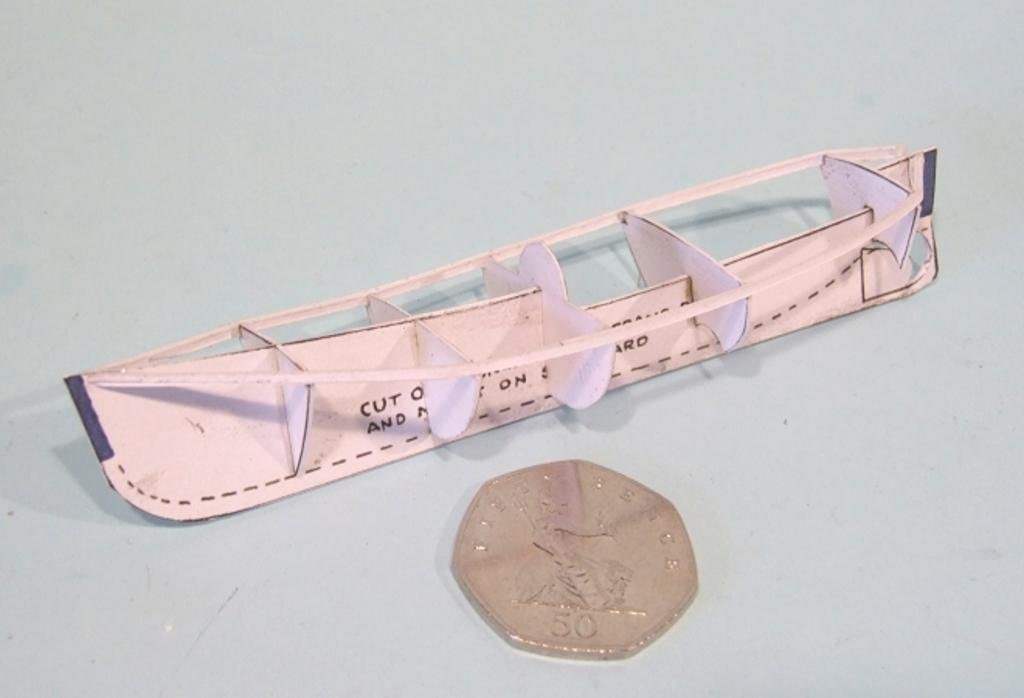What is located in the foreground of the image? There is a coin and a cardboard object in the foreground of the image. What is the color of the surface on which the objects are placed? The objects are on a white surface. How many cherries are on the toothbrush in the image? There is no toothbrush or cherries present in the image. 